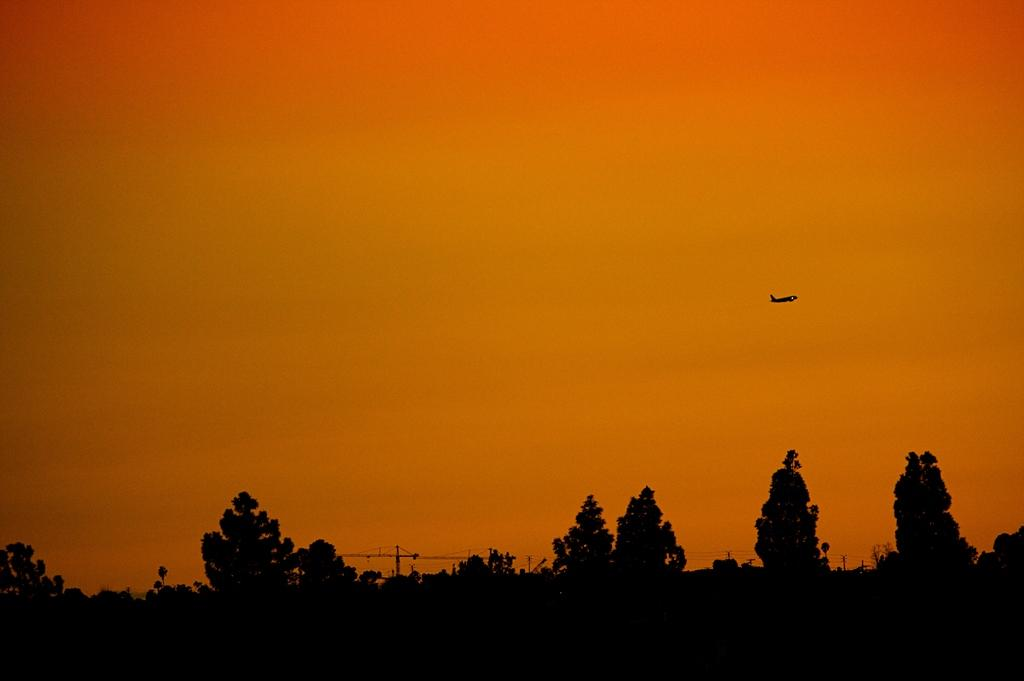What type of vegetation is at the bottom of the image? There are trees at the bottom of the image. What is the main subject in the image? There is an aeroplane in the image. What can be seen in the background of the image? There is a sky visible in the background of the image. What type of beef is being served at the    picnic in the image? There is no picnic or beef present in the image; it features trees and an aeroplane. How many thumbs can be seen in the image? There are no thumbs visible in the image. 